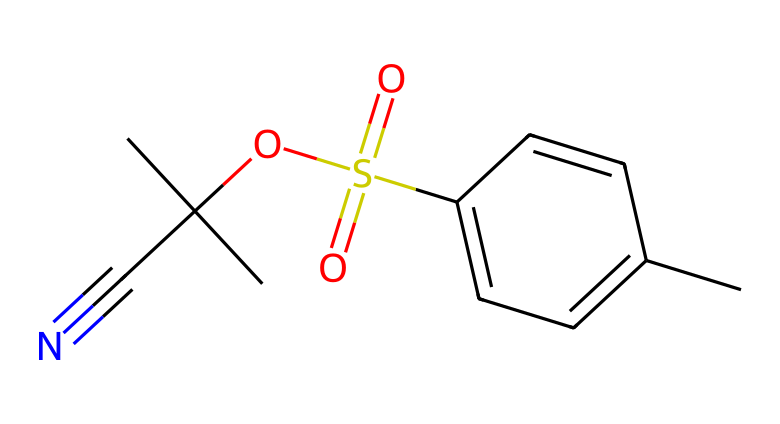What is the molecular formula of the compound? Analyzing the provided SMILES representation, we can count the number of each type of atom: there are 10 carbons (C), 13 hydrogens (H), 1 sulfur (S), and 2 oxygens (O). Thus, the molecular formula is C10H13O2S.
Answer: C10H13O2S How many double bonds are present in the structure? By inspecting the SMILES notation, we can identify two double bonds: one in the aromatic ring and one in the sulfonate group. This leads to a total of two double bonds.
Answer: 2 What functional groups are present in this compound? In the structure, we can identify a sulfonate group (-SO2-), an alkyne (C#N), and an ether group (C-O-C), showcasing the presence of multiple functional groups.
Answer: sulfonate, alkyne, ether What type of reaction can this photoresist undergo upon exposure to light? Chemically amplified photoresists often undergo cleavage or deprotection reactions upon exposure to UV light, leading to the formation of acid that catalyzes further reactions.
Answer: deprotection Which part of the molecule is responsible for its photoresponsive behavior? The presence of the sulfonate group, along with the chemical structure allowing for acid generation upon light exposure, contributes to the light sensitivity of this compound.
Answer: sulfonate group What is the total number of rings in the structure? The SMILES notation indicates the presence of one aromatic ring in the chemical structure. Thus, there is a total of one ring.
Answer: 1 Is this chemical polar or nonpolar? Given the presence of the sulfonate and ether functionalities, the molecule is likely polar due to the electronegative atoms and the functional groups present.
Answer: polar 